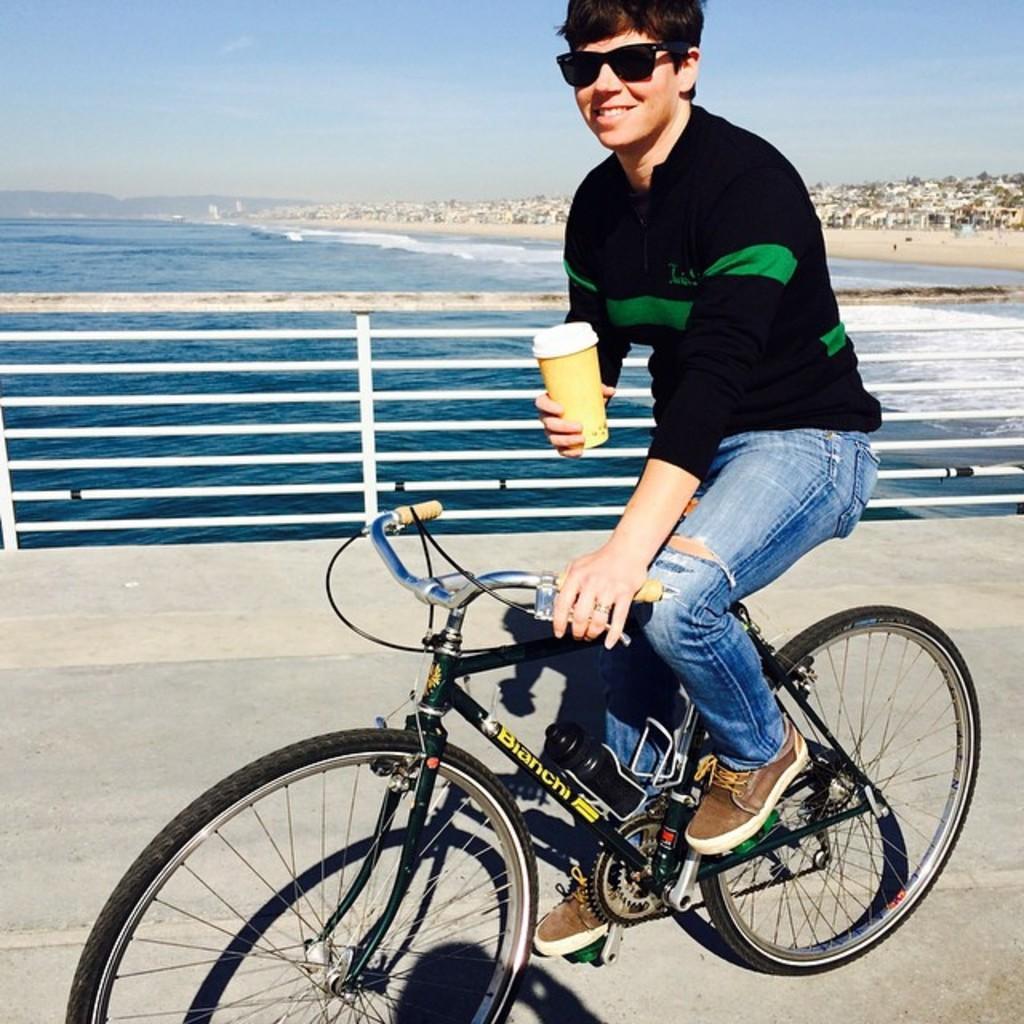How would you summarize this image in a sentence or two? Here we can see a man riding a bicycle holding a cup of coffee in his hand, he is wearing goggles and behind him we can see a railing and a sea present 